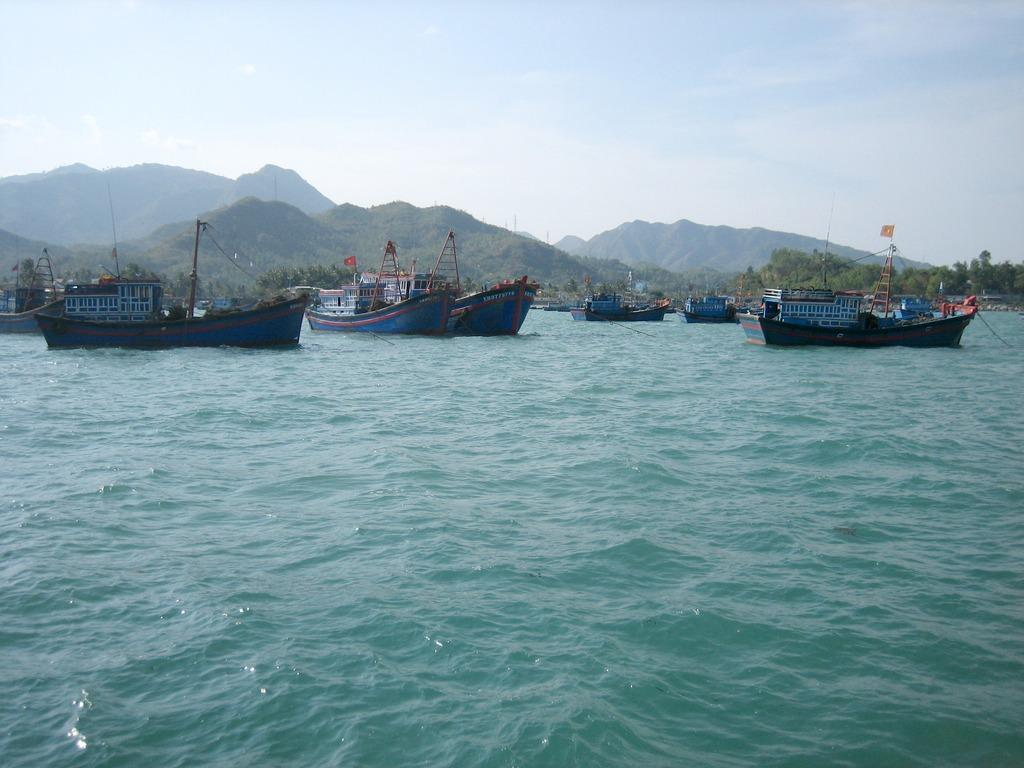What is in the water in the image? There are boats in the water in the image. What type of vegetation can be seen in the image? There are trees in the image. What is the color of the trees? The trees are green. What type of landscape feature is visible in the image? There are mountains in the image. What is the color of the sky in the image? The sky is blue and white. What is the weight of the dust particles in the image? There is no dust present in the image, so it is not possible to determine the weight of any dust particles. 